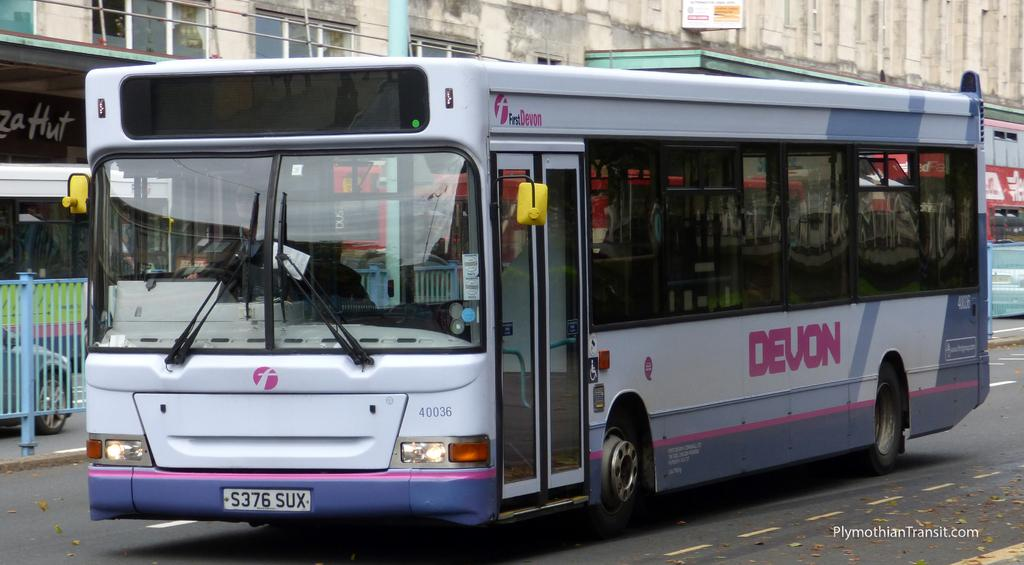<image>
Describe the image concisely. White and purple bus with the plate S376SUX on the front. 